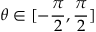Convert formula to latex. <formula><loc_0><loc_0><loc_500><loc_500>\theta \in [ - \frac { \pi } { 2 } , \frac { \pi } { 2 } ]</formula> 